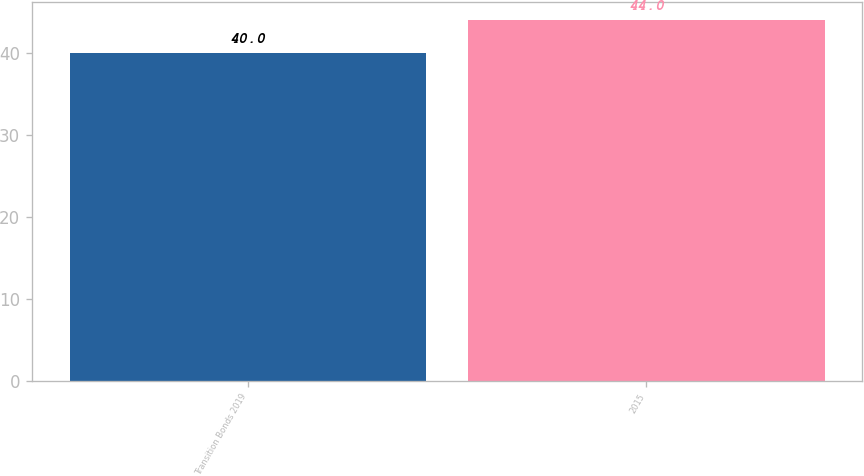Convert chart. <chart><loc_0><loc_0><loc_500><loc_500><bar_chart><fcel>Transition Bonds 2019<fcel>2015<nl><fcel>40<fcel>44<nl></chart> 